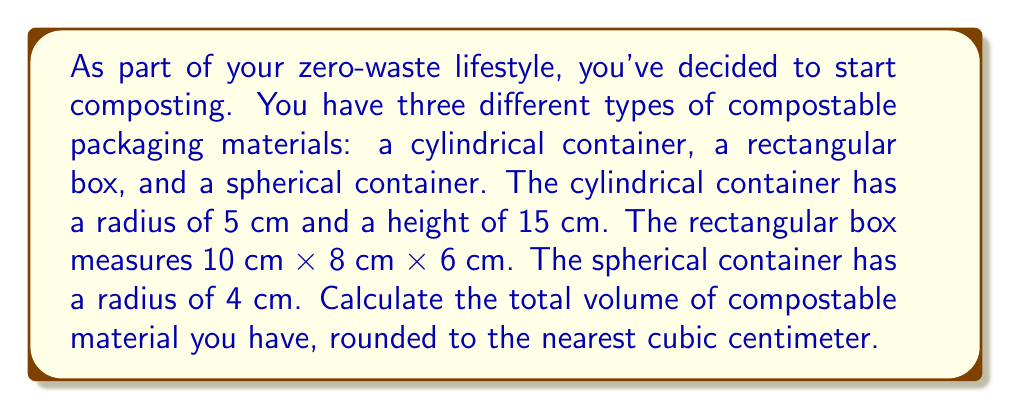Show me your answer to this math problem. To solve this problem, we need to calculate the volume of each container and then sum them up.

1. Cylindrical container:
The volume of a cylinder is given by the formula $V = \pi r^2 h$, where $r$ is the radius and $h$ is the height.
$$V_{cylinder} = \pi \cdot (5\text{ cm})^2 \cdot 15\text{ cm} = 375\pi \text{ cm}^3 \approx 1,178.10 \text{ cm}^3$$

2. Rectangular box:
The volume of a rectangular box is given by the formula $V = l \cdot w \cdot h$, where $l$ is length, $w$ is width, and $h$ is height.
$$V_{box} = 10\text{ cm} \cdot 8\text{ cm} \cdot 6\text{ cm} = 480 \text{ cm}^3$$

3. Spherical container:
The volume of a sphere is given by the formula $V = \frac{4}{3}\pi r^3$, where $r$ is the radius.
$$V_{sphere} = \frac{4}{3}\pi \cdot (4\text{ cm})^3 = \frac{256}{3}\pi \text{ cm}^3 \approx 268.08 \text{ cm}^3$$

Now, we sum up the volumes of all three containers:
$$V_{total} = V_{cylinder} + V_{box} + V_{sphere}$$
$$V_{total} = 1,178.10 \text{ cm}^3 + 480 \text{ cm}^3 + 268.08 \text{ cm}^3 = 1,926.18 \text{ cm}^3$$

Rounding to the nearest cubic centimeter, we get 1,926 cm³.
Answer: 1,926 cm³ 